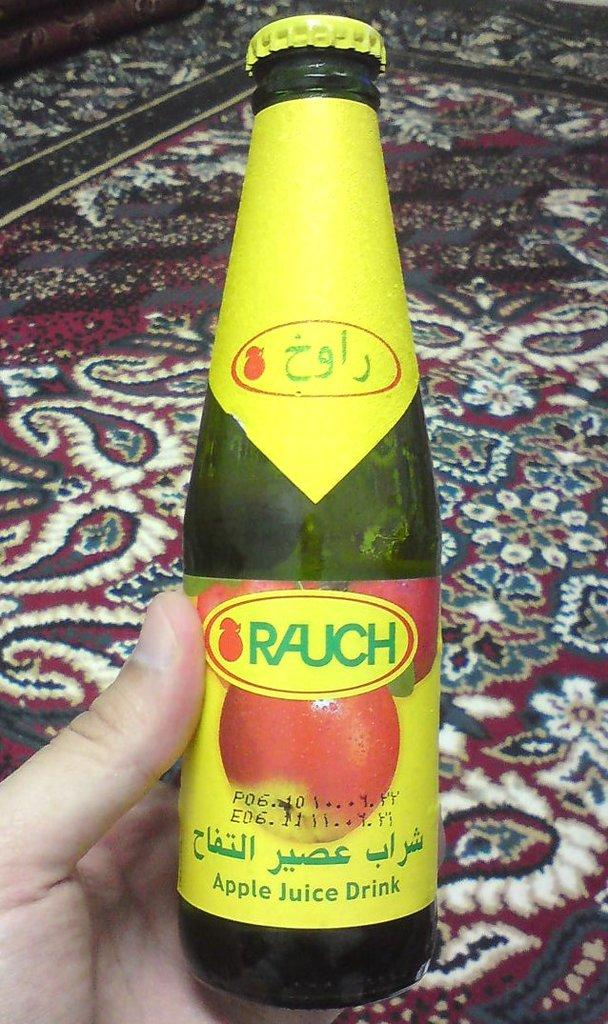<image>
Offer a succinct explanation of the picture presented. a person holding onto some yellow bottle in their hand with Rauch on it 